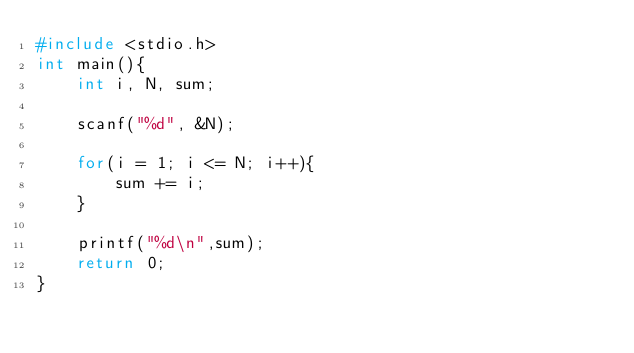Convert code to text. <code><loc_0><loc_0><loc_500><loc_500><_C_>#include <stdio.h>
int main(){
    int i, N, sum;
    
    scanf("%d", &N);
    
    for(i = 1; i <= N; i++){
        sum += i;
    }
    
    printf("%d\n",sum);
    return 0;
}

</code> 